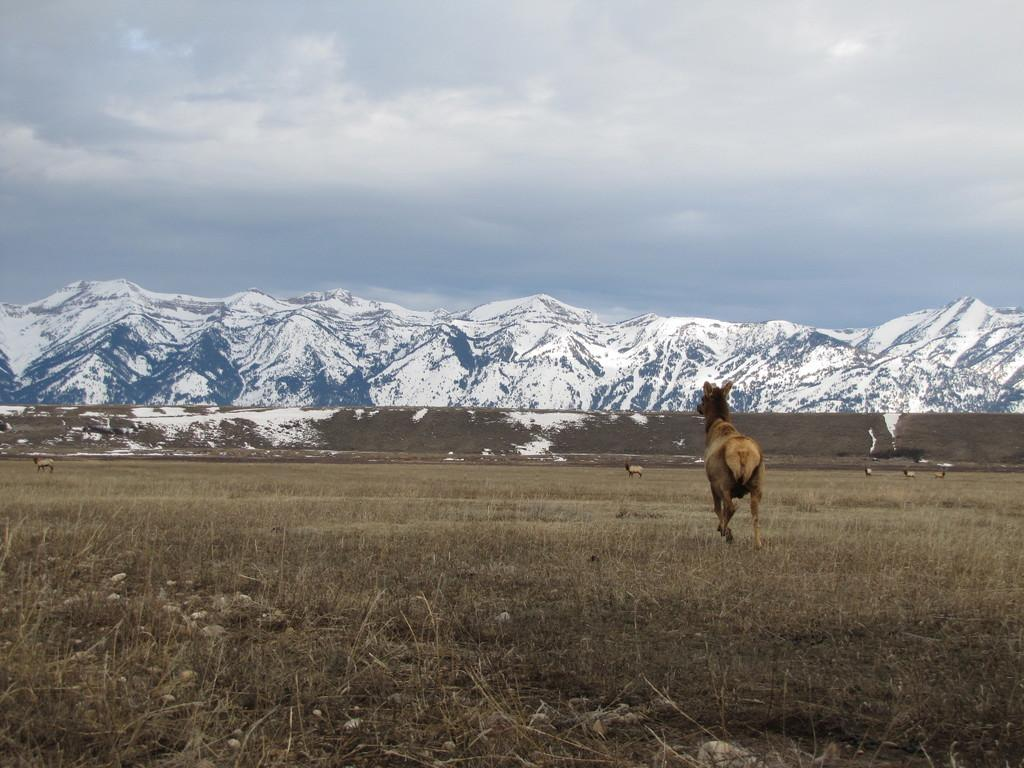What types of living organisms can be seen in the image? There are animals in the image. What type of natural landscape is visible in the image? There are hills and grass in the image. What type of snake can be seen slithering through the grass in the image? There is no snake present in the image; only animals are mentioned. 